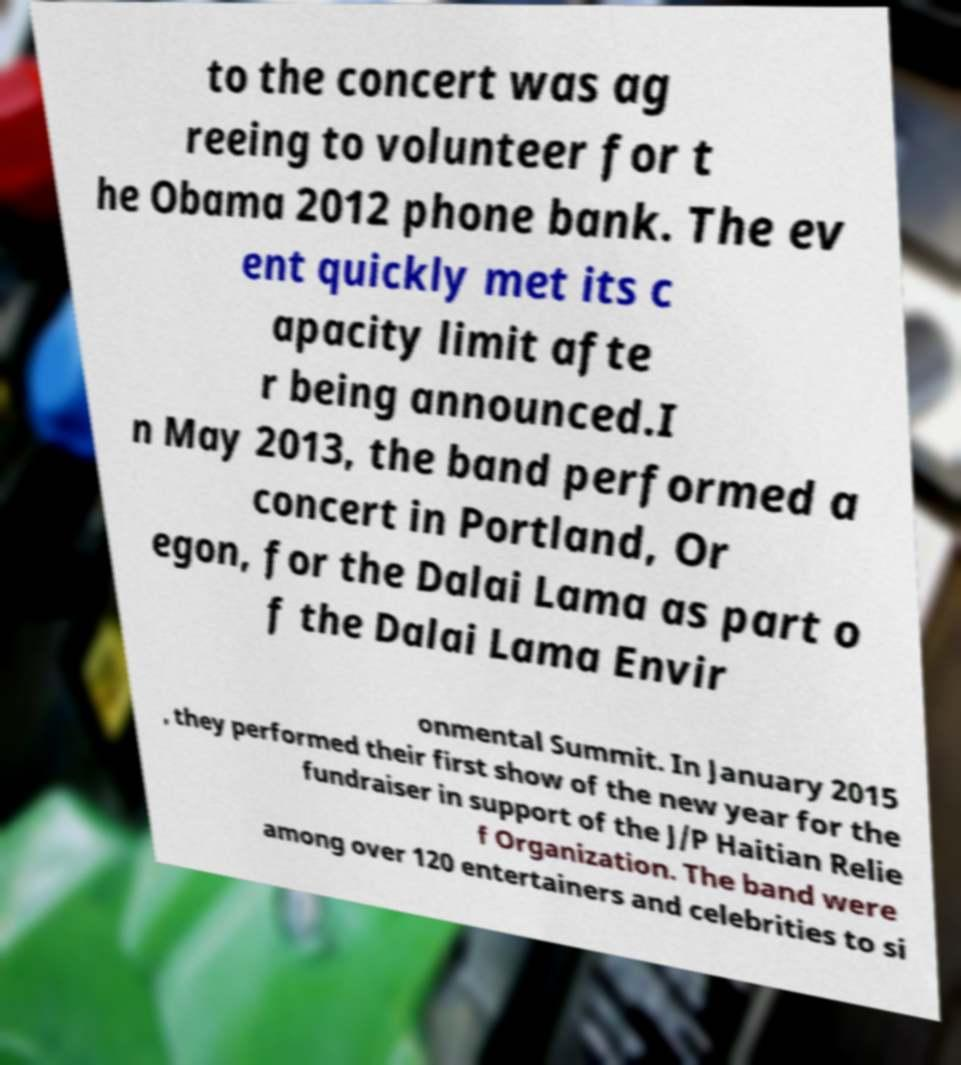For documentation purposes, I need the text within this image transcribed. Could you provide that? to the concert was ag reeing to volunteer for t he Obama 2012 phone bank. The ev ent quickly met its c apacity limit afte r being announced.I n May 2013, the band performed a concert in Portland, Or egon, for the Dalai Lama as part o f the Dalai Lama Envir onmental Summit. In January 2015 , they performed their first show of the new year for the fundraiser in support of the J/P Haitian Relie f Organization. The band were among over 120 entertainers and celebrities to si 